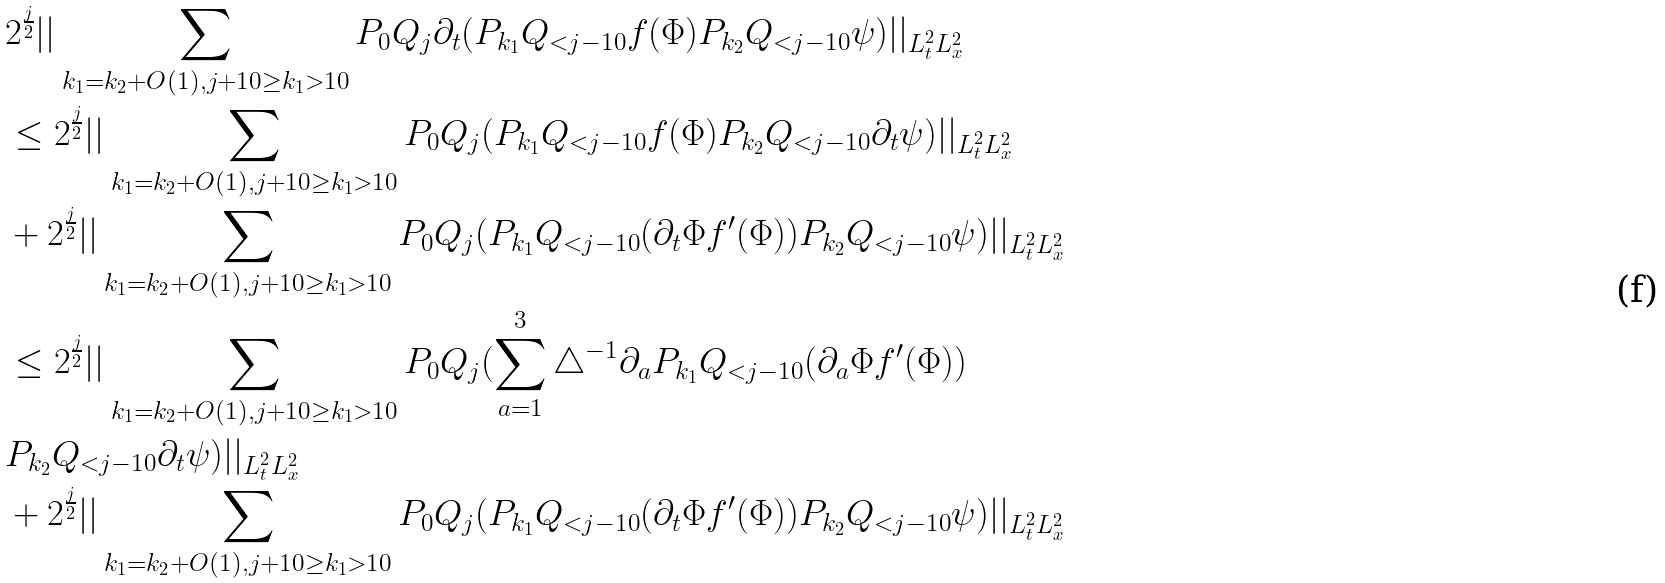<formula> <loc_0><loc_0><loc_500><loc_500>& 2 ^ { \frac { j } { 2 } } | | \sum _ { k _ { 1 } = k _ { 2 } + O ( 1 ) , j + 1 0 \geq k _ { 1 } > 1 0 } P _ { 0 } Q _ { j } \partial _ { t } ( P _ { k _ { 1 } } Q _ { < j - 1 0 } f ( \Phi ) P _ { k _ { 2 } } Q _ { < j - 1 0 } \psi ) | | _ { L _ { t } ^ { 2 } L _ { x } ^ { 2 } } \\ & \leq 2 ^ { \frac { j } { 2 } } | | \sum _ { k _ { 1 } = k _ { 2 } + O ( 1 ) , j + 1 0 \geq k _ { 1 } > 1 0 } P _ { 0 } Q _ { j } ( P _ { k _ { 1 } } Q _ { < j - 1 0 } f ( \Phi ) P _ { k _ { 2 } } Q _ { < j - 1 0 } \partial _ { t } \psi ) | | _ { L _ { t } ^ { 2 } L _ { x } ^ { 2 } } \\ & + 2 ^ { \frac { j } { 2 } } | | \sum _ { k _ { 1 } = k _ { 2 } + O ( 1 ) , j + 1 0 \geq k _ { 1 } > 1 0 } P _ { 0 } Q _ { j } ( P _ { k _ { 1 } } Q _ { < j - 1 0 } ( \partial _ { t } \Phi f ^ { \prime } ( \Phi ) ) P _ { k _ { 2 } } Q _ { < j - 1 0 } \psi ) | | _ { L _ { t } ^ { 2 } L _ { x } ^ { 2 } } \\ & \leq 2 ^ { \frac { j } { 2 } } | | \sum _ { k _ { 1 } = k _ { 2 } + O ( 1 ) , j + 1 0 \geq k _ { 1 } > 1 0 } P _ { 0 } Q _ { j } ( \sum _ { a = 1 } ^ { 3 } \triangle ^ { - 1 } \partial _ { a } P _ { k _ { 1 } } Q _ { < j - 1 0 } ( \partial _ { a } \Phi f ^ { \prime } ( \Phi ) ) \\ & P _ { k _ { 2 } } Q _ { < j - 1 0 } \partial _ { t } \psi ) | | _ { L _ { t } ^ { 2 } L _ { x } ^ { 2 } } \\ & + 2 ^ { \frac { j } { 2 } } | | \sum _ { k _ { 1 } = k _ { 2 } + O ( 1 ) , j + 1 0 \geq k _ { 1 } > 1 0 } P _ { 0 } Q _ { j } ( P _ { k _ { 1 } } Q _ { < j - 1 0 } ( \partial _ { t } \Phi f ^ { \prime } ( \Phi ) ) P _ { k _ { 2 } } Q _ { < j - 1 0 } \psi ) | | _ { L _ { t } ^ { 2 } L _ { x } ^ { 2 } } \\</formula> 